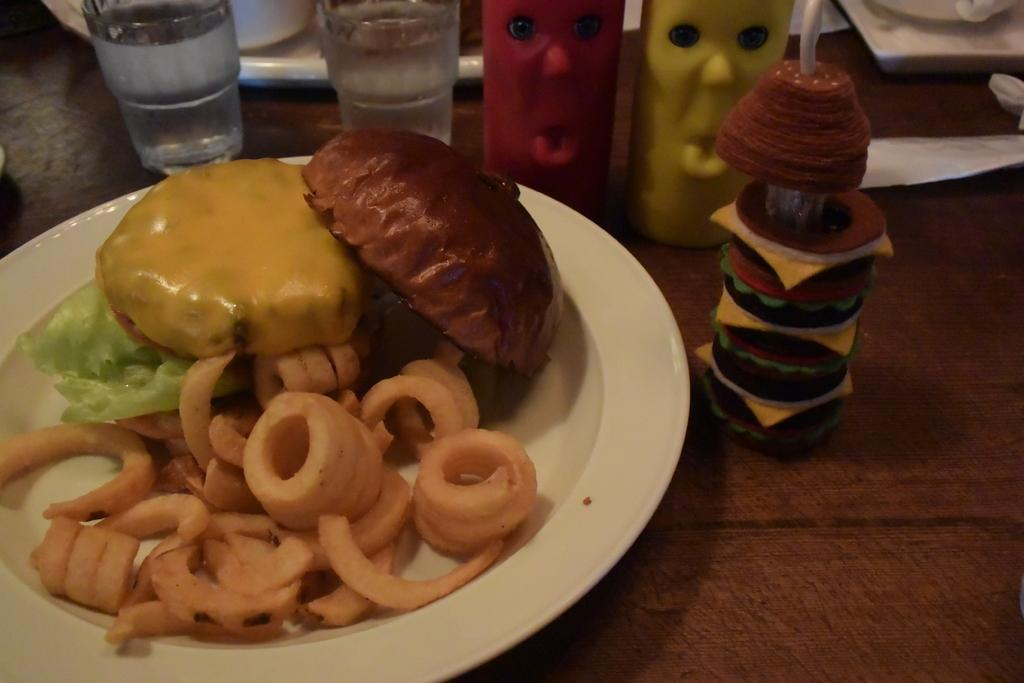What is on the table in the image? There is a glass, a plate, and a straw on the table. What is on the plate? There is bread, cabbage, cheese, and other food items on the plate. How many objects are on the table? There are at least four objects on the table: a glass, a plate, a straw, and other objects. What is the reaction of the glass to the cabbage in the image? There is no reaction of the glass to the cabbage in the image, as the glass is an inanimate object and cannot have a reaction. 